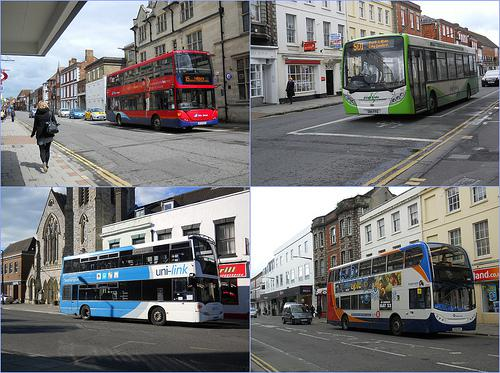Question: what is in every picture?
Choices:
A. A car.
B. A bus.
C. A truck.
D. A bicycle.
Answer with the letter. Answer: B Question: when were these pictures taken?
Choices:
A. During the morning.
B. During the afternoon.
C. During the day.
D. During the evening.
Answer with the letter. Answer: C Question: how many buses are there?
Choices:
A. Four.
B. Five.
C. Six.
D. Eighteen.
Answer with the letter. Answer: A Question: what is the color of the bus on the top left?
Choices:
A. Blue with little red.
B. White with little blue.
C. Yellow with little red.
D. Red with little blue.
Answer with the letter. Answer: D Question: what number bus is the green one?
Choices:
A. 501.
B. 522.
C. 602.
D. 503.
Answer with the letter. Answer: A Question: what does it say on the bottom left bus?
Choices:
A. Greyhound.
B. Megabus.
C. Uni-link.
D. Hotard Coaches.
Answer with the letter. Answer: C 